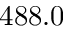Convert formula to latex. <formula><loc_0><loc_0><loc_500><loc_500>4 8 8 . 0</formula> 